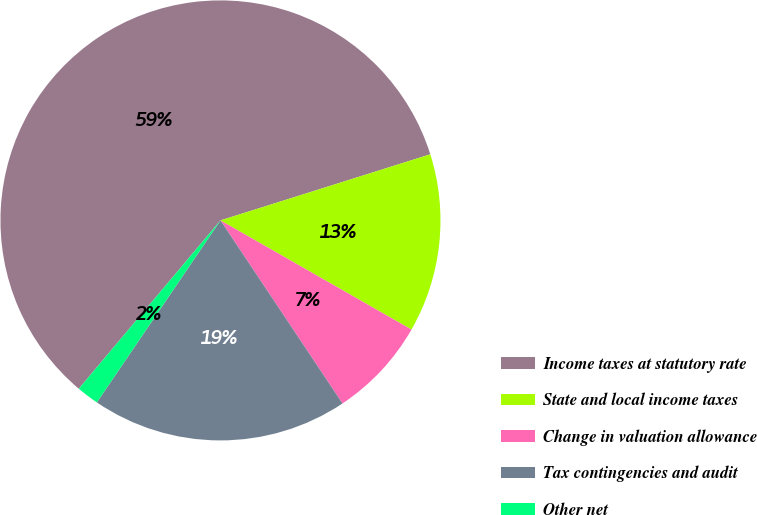Convert chart to OTSL. <chart><loc_0><loc_0><loc_500><loc_500><pie_chart><fcel>Income taxes at statutory rate<fcel>State and local income taxes<fcel>Change in valuation allowance<fcel>Tax contingencies and audit<fcel>Other net<nl><fcel>59.01%<fcel>13.12%<fcel>7.38%<fcel>18.85%<fcel>1.64%<nl></chart> 